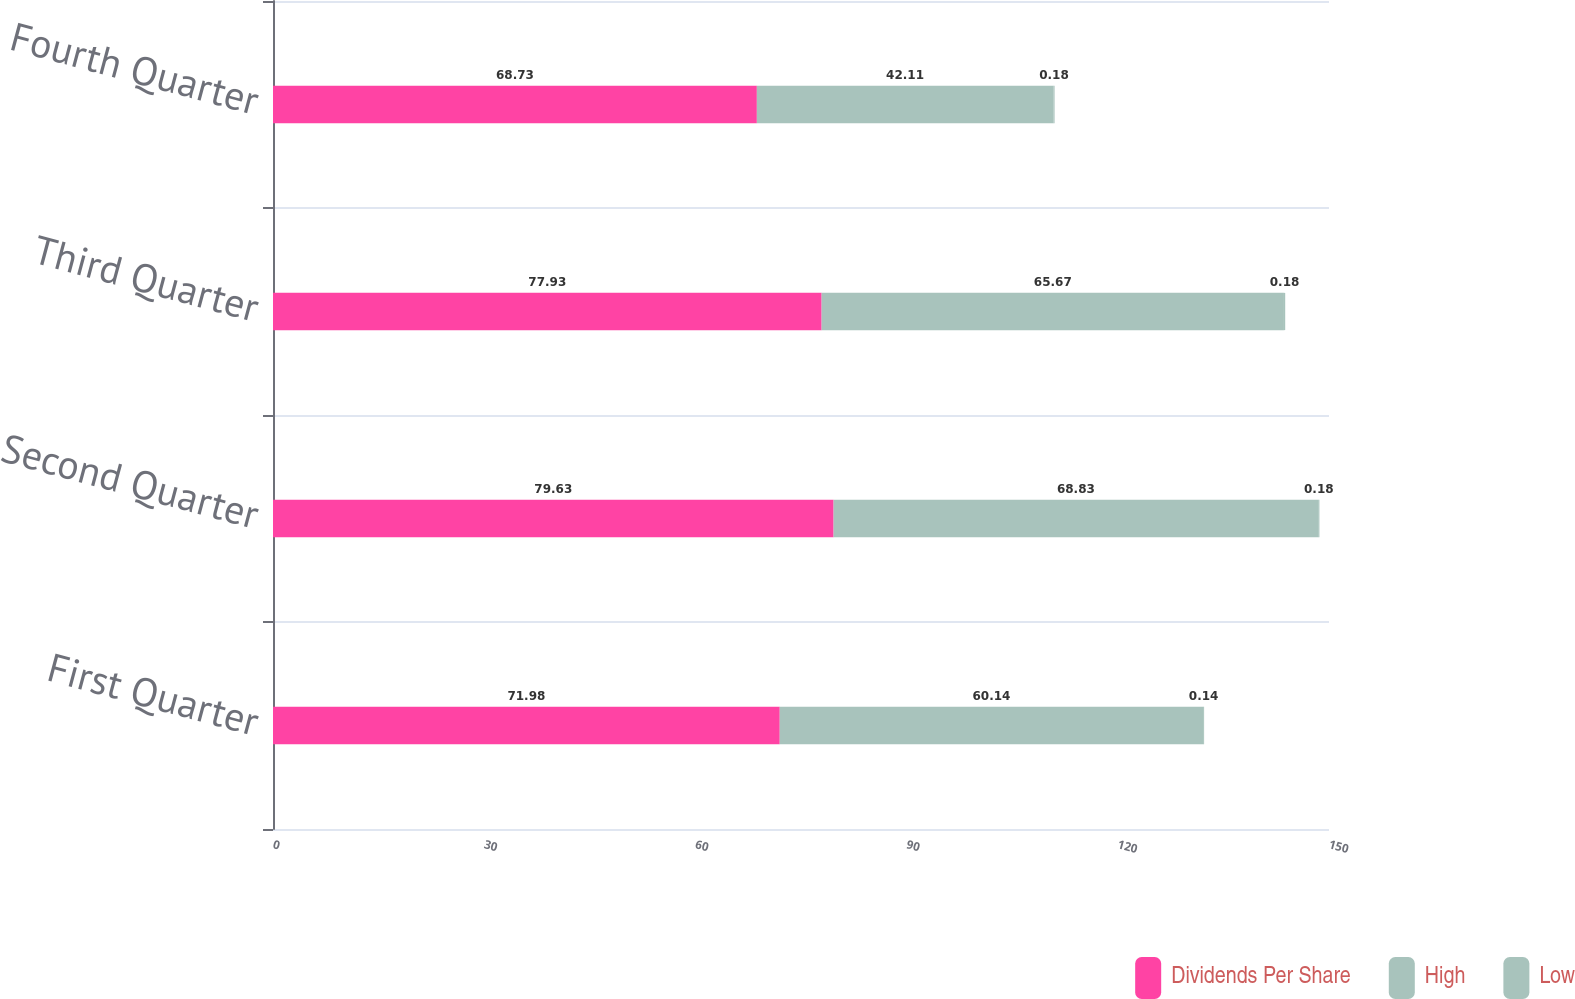Convert chart to OTSL. <chart><loc_0><loc_0><loc_500><loc_500><stacked_bar_chart><ecel><fcel>First Quarter<fcel>Second Quarter<fcel>Third Quarter<fcel>Fourth Quarter<nl><fcel>Dividends Per Share<fcel>71.98<fcel>79.63<fcel>77.93<fcel>68.73<nl><fcel>High<fcel>60.14<fcel>68.83<fcel>65.67<fcel>42.11<nl><fcel>Low<fcel>0.14<fcel>0.18<fcel>0.18<fcel>0.18<nl></chart> 